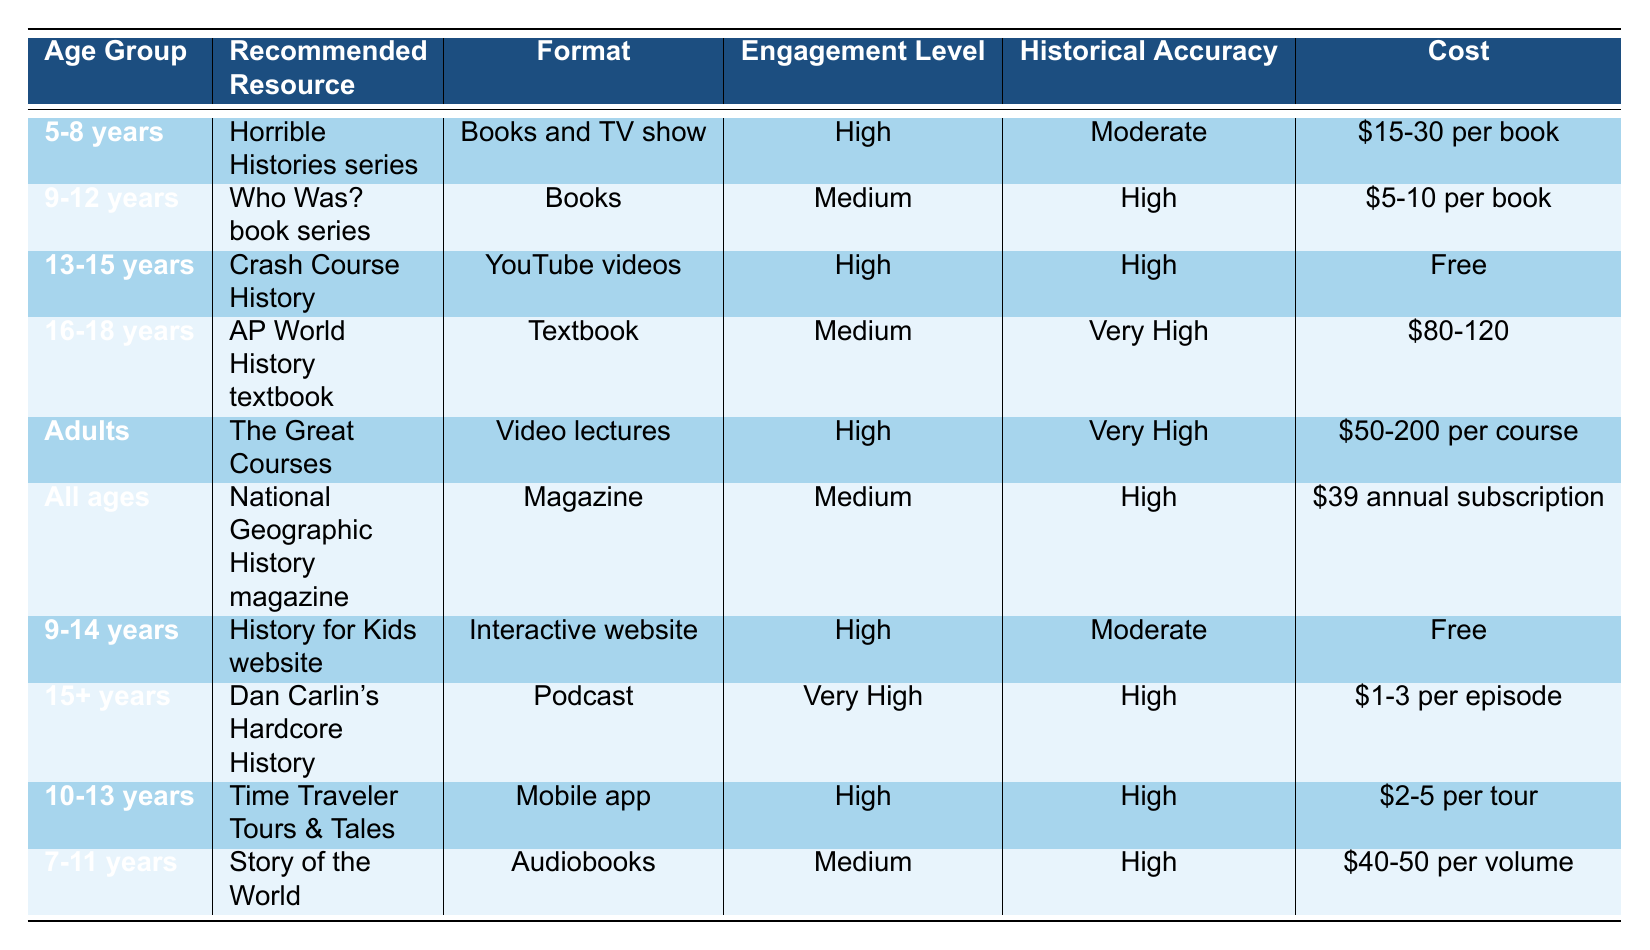What is the cost of the Horrible Histories series for the 5-8 years age group? The table indicates the cost of the Horrible Histories series is listed as $15-30 per book for the 5-8 years age group.
Answer: $15-30 per book Which age group has the highest engagement level? By skimming through the engagement levels listed in the table, both the 5-8 years and 13-15 years age groups are rated as "High," while the 15+ years age group is rated as "Very High." Thus, the 15+ years age group has the highest engagement level.
Answer: 15+ years Is the historical accuracy of the AP World History textbook very high? The table specifies that the historical accuracy for the AP World History textbook in the 16-18 years age group is classified as "Very High." Therefore, this statement is true.
Answer: Yes What is the average cost of resources for the age group of 9-12 years? The resources for 9-12 years consist of two items: Who Was? book series at $5-10 per book and History for Kids website which is free. To find the average cost, we take the average of the highest and lowest prices of Who Was?, which is $7.50, and because the website is free, the average cost is $7.50.
Answer: $7.50 Which resources are available for both children and adults? In the table, the "National Geographic History magazine" is marked for "All ages," making it suitable for both children and adults.
Answer: National Geographic History magazine What is the total cost range for the adults' resource, The Great Courses? The specific cost range for The Great Courses resource is given as $50-200 per course in the adults' category. Summing the lowest and highest values gives a total range of $50 to $200.
Answer: $50-200 Which age group utilizes YouTube videos as a resource? Referring to the table, the 13-15 years age group uses "Crash Course History," which is available in YouTube video format.
Answer: 13-15 years Do all resources for 7-11 years have high historical accuracy? The only resource listed for the 7-11 years age group is "Story of the World," which has a historical accuracy labeled as "High." Therefore, in this case, yes, it maintains high historical accuracy.
Answer: Yes What is the engagement level for the 10-13 years age group? The table shows that the resource "Time Traveler Tours & Tales" for the 10-13 years category has an engagement level rated as "High."
Answer: High How many resources are provided for the age group of 9-14 years? The age group of 9-14 years includes two resources: the Who Was? book series for the 9-12 years age group and the History for Kids website for the 9-14 years age category. Therefore, the total is two resources.
Answer: 2 